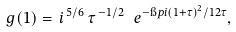<formula> <loc_0><loc_0><loc_500><loc_500>\ g ( 1 ) = \, i ^ { \, 5 / 6 } \, \tau ^ { \, - 1 / 2 } \, \ e ^ { - \i p i ( 1 + \tau ) ^ { 2 } / 1 2 \tau } ,</formula> 